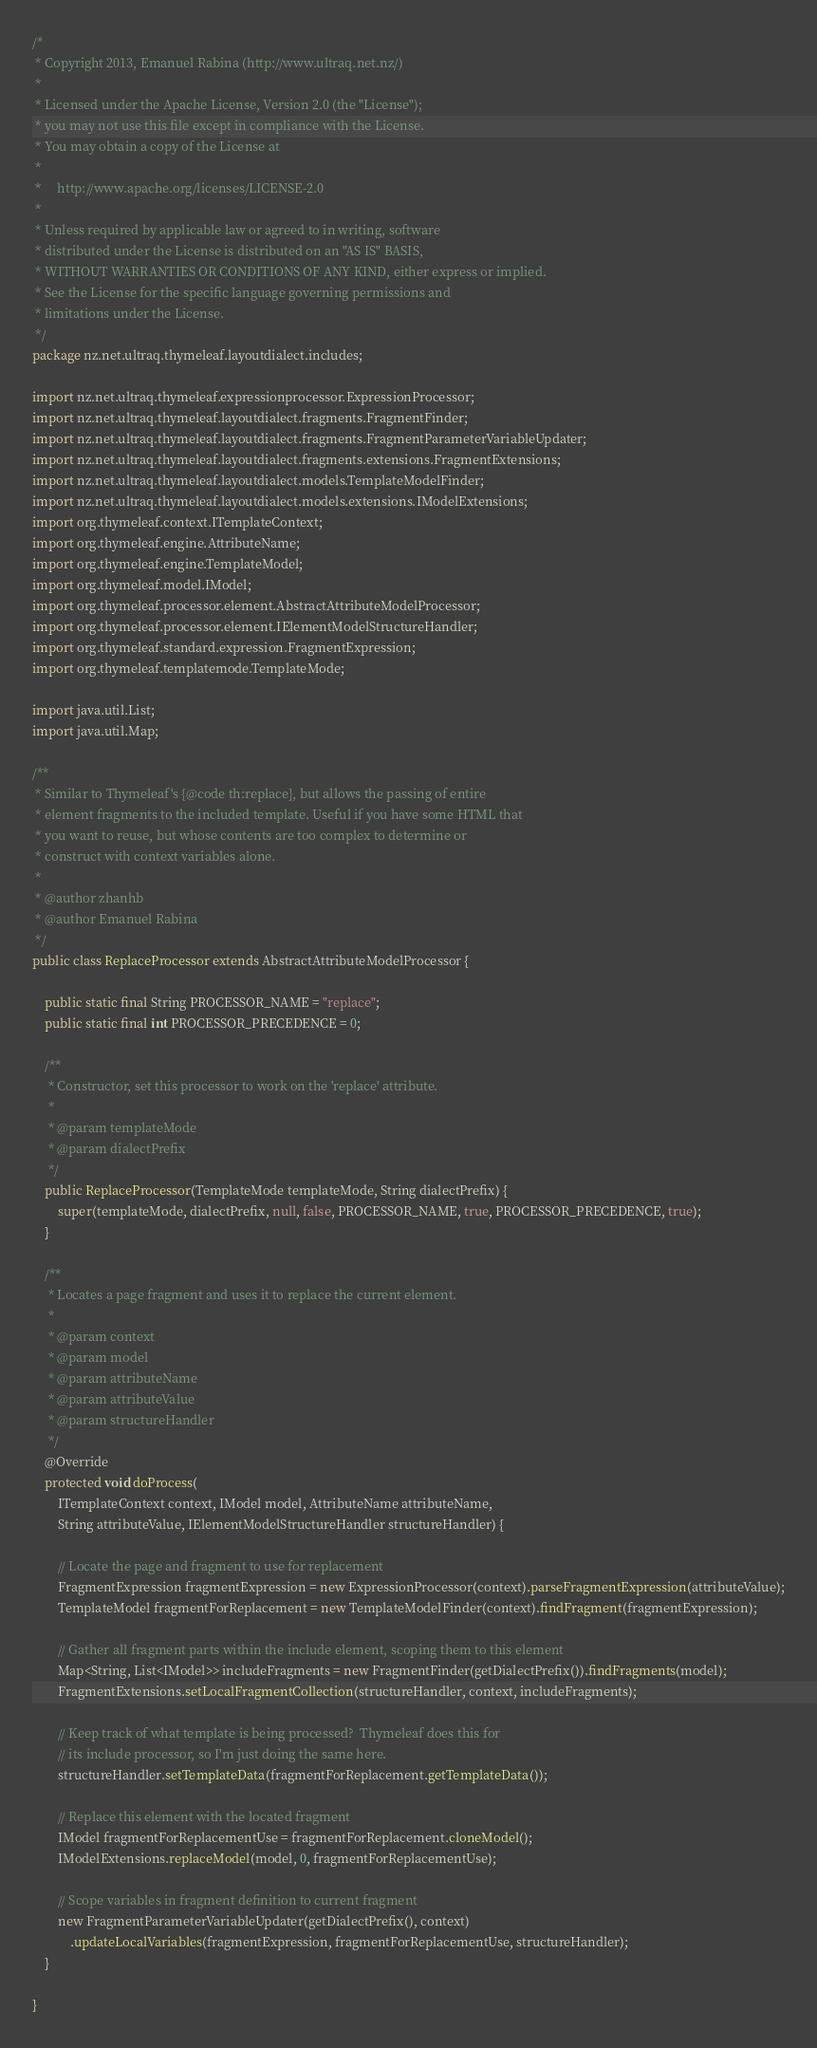<code> <loc_0><loc_0><loc_500><loc_500><_Java_>/*
 * Copyright 2013, Emanuel Rabina (http://www.ultraq.net.nz/)
 *
 * Licensed under the Apache License, Version 2.0 (the "License");
 * you may not use this file except in compliance with the License.
 * You may obtain a copy of the License at
 *
 *     http://www.apache.org/licenses/LICENSE-2.0
 *
 * Unless required by applicable law or agreed to in writing, software
 * distributed under the License is distributed on an "AS IS" BASIS,
 * WITHOUT WARRANTIES OR CONDITIONS OF ANY KIND, either express or implied.
 * See the License for the specific language governing permissions and
 * limitations under the License.
 */
package nz.net.ultraq.thymeleaf.layoutdialect.includes;

import nz.net.ultraq.thymeleaf.expressionprocessor.ExpressionProcessor;
import nz.net.ultraq.thymeleaf.layoutdialect.fragments.FragmentFinder;
import nz.net.ultraq.thymeleaf.layoutdialect.fragments.FragmentParameterVariableUpdater;
import nz.net.ultraq.thymeleaf.layoutdialect.fragments.extensions.FragmentExtensions;
import nz.net.ultraq.thymeleaf.layoutdialect.models.TemplateModelFinder;
import nz.net.ultraq.thymeleaf.layoutdialect.models.extensions.IModelExtensions;
import org.thymeleaf.context.ITemplateContext;
import org.thymeleaf.engine.AttributeName;
import org.thymeleaf.engine.TemplateModel;
import org.thymeleaf.model.IModel;
import org.thymeleaf.processor.element.AbstractAttributeModelProcessor;
import org.thymeleaf.processor.element.IElementModelStructureHandler;
import org.thymeleaf.standard.expression.FragmentExpression;
import org.thymeleaf.templatemode.TemplateMode;

import java.util.List;
import java.util.Map;

/**
 * Similar to Thymeleaf's {@code th:replace}, but allows the passing of entire
 * element fragments to the included template. Useful if you have some HTML that
 * you want to reuse, but whose contents are too complex to determine or
 * construct with context variables alone.
 *
 * @author zhanhb
 * @author Emanuel Rabina
 */
public class ReplaceProcessor extends AbstractAttributeModelProcessor {

	public static final String PROCESSOR_NAME = "replace";
	public static final int PROCESSOR_PRECEDENCE = 0;

	/**
	 * Constructor, set this processor to work on the 'replace' attribute.
	 *
	 * @param templateMode
	 * @param dialectPrefix
	 */
	public ReplaceProcessor(TemplateMode templateMode, String dialectPrefix) {
		super(templateMode, dialectPrefix, null, false, PROCESSOR_NAME, true, PROCESSOR_PRECEDENCE, true);
	}

	/**
	 * Locates a page fragment and uses it to replace the current element.
	 *
	 * @param context
	 * @param model
	 * @param attributeName
	 * @param attributeValue
	 * @param structureHandler
	 */
	@Override
	protected void doProcess(
		ITemplateContext context, IModel model, AttributeName attributeName,
		String attributeValue, IElementModelStructureHandler structureHandler) {

		// Locate the page and fragment to use for replacement
		FragmentExpression fragmentExpression = new ExpressionProcessor(context).parseFragmentExpression(attributeValue);
		TemplateModel fragmentForReplacement = new TemplateModelFinder(context).findFragment(fragmentExpression);

		// Gather all fragment parts within the include element, scoping them to this element
		Map<String, List<IModel>> includeFragments = new FragmentFinder(getDialectPrefix()).findFragments(model);
		FragmentExtensions.setLocalFragmentCollection(structureHandler, context, includeFragments);

		// Keep track of what template is being processed?  Thymeleaf does this for
		// its include processor, so I'm just doing the same here.
		structureHandler.setTemplateData(fragmentForReplacement.getTemplateData());

		// Replace this element with the located fragment
		IModel fragmentForReplacementUse = fragmentForReplacement.cloneModel();
		IModelExtensions.replaceModel(model, 0, fragmentForReplacementUse);

		// Scope variables in fragment definition to current fragment
		new FragmentParameterVariableUpdater(getDialectPrefix(), context)
			.updateLocalVariables(fragmentExpression, fragmentForReplacementUse, structureHandler);
	}

}
</code> 